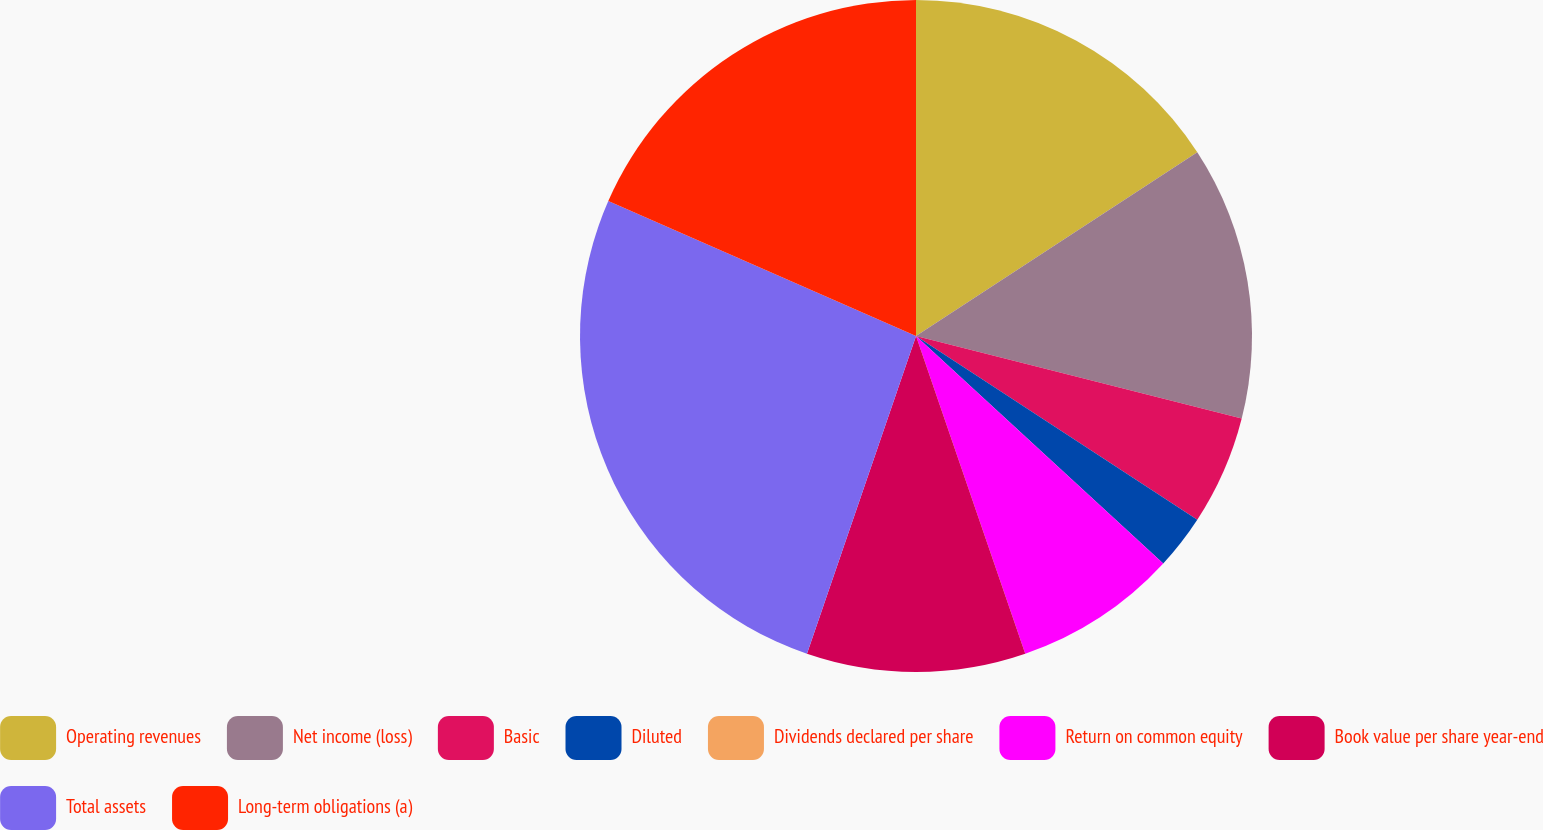Convert chart to OTSL. <chart><loc_0><loc_0><loc_500><loc_500><pie_chart><fcel>Operating revenues<fcel>Net income (loss)<fcel>Basic<fcel>Diluted<fcel>Dividends declared per share<fcel>Return on common equity<fcel>Book value per share year-end<fcel>Total assets<fcel>Long-term obligations (a)<nl><fcel>15.79%<fcel>13.16%<fcel>5.26%<fcel>2.63%<fcel>0.0%<fcel>7.89%<fcel>10.53%<fcel>26.32%<fcel>18.42%<nl></chart> 